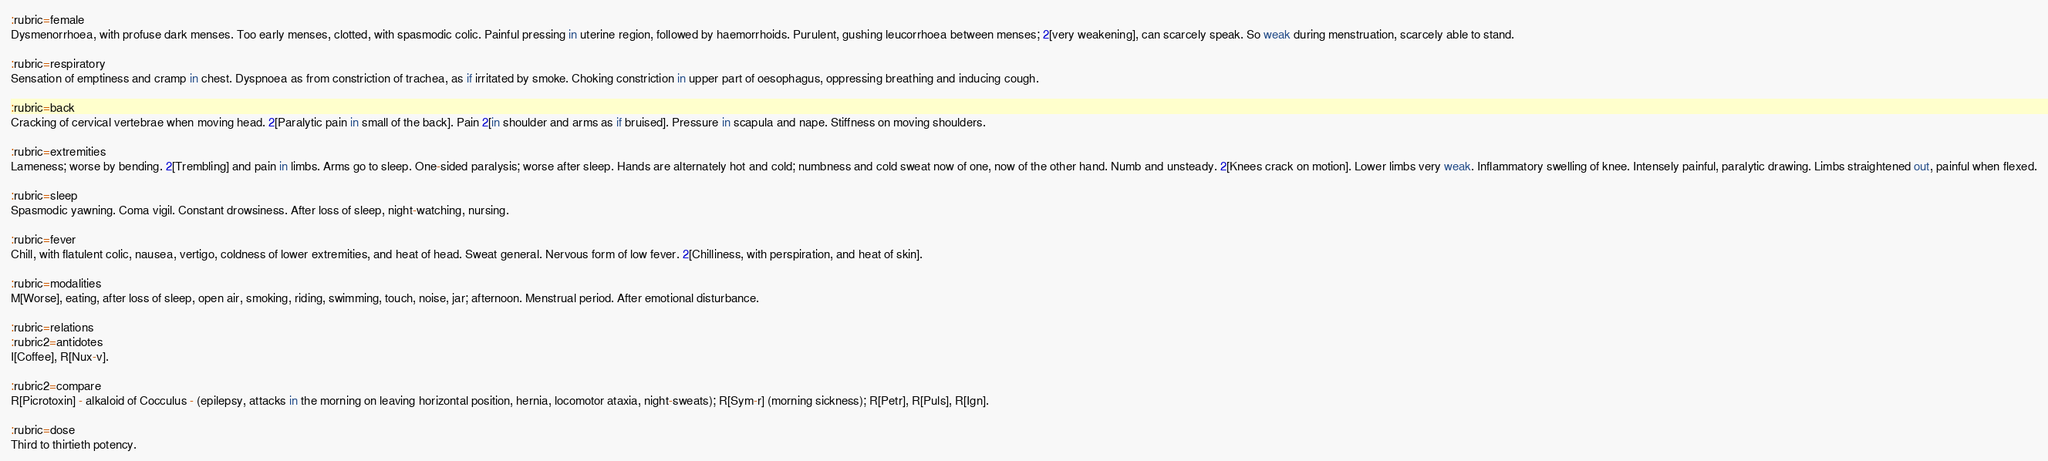<code> <loc_0><loc_0><loc_500><loc_500><_ObjectiveC_>:rubric=female
Dysmenorrhoea, with profuse dark menses. Too early menses, clotted, with spasmodic colic. Painful pressing in uterine region, followed by haemorrhoids. Purulent, gushing leucorrhoea between menses; 2[very weakening], can scarcely speak. So weak during menstruation, scarcely able to stand.

:rubric=respiratory
Sensation of emptiness and cramp in chest. Dyspnoea as from constriction of trachea, as if irritated by smoke. Choking constriction in upper part of oesophagus, oppressing breathing and inducing cough.

:rubric=back
Cracking of cervical vertebrae when moving head. 2[Paralytic pain in small of the back]. Pain 2[in shoulder and arms as if bruised]. Pressure in scapula and nape. Stiffness on moving shoulders.

:rubric=extremities
Lameness; worse by bending. 2[Trembling] and pain in limbs. Arms go to sleep. One-sided paralysis; worse after sleep. Hands are alternately hot and cold; numbness and cold sweat now of one, now of the other hand. Numb and unsteady. 2[Knees crack on motion]. Lower limbs very weak. Inflammatory swelling of knee. Intensely painful, paralytic drawing. Limbs straightened out, painful when flexed.

:rubric=sleep
Spasmodic yawning. Coma vigil. Constant drowsiness. After loss of sleep, night-watching, nursing.

:rubric=fever
Chill, with flatulent colic, nausea, vertigo, coldness of lower extremities, and heat of head. Sweat general. Nervous form of low fever. 2[Chilliness, with perspiration, and heat of skin].

:rubric=modalities
M[Worse], eating, after loss of sleep, open air, smoking, riding, swimming, touch, noise, jar; afternoon. Menstrual period. After emotional disturbance.

:rubric=relations
:rubric2=antidotes
I[Coffee], R[Nux-v].

:rubric2=compare
R[Picrotoxin] - alkaloid of Cocculus - (epilepsy, attacks in the morning on leaving horizontal position, hernia, locomotor ataxia, night-sweats); R[Sym-r] (morning sickness); R[Petr], R[Puls], R[Ign].

:rubric=dose
Third to thirtieth potency.</code> 